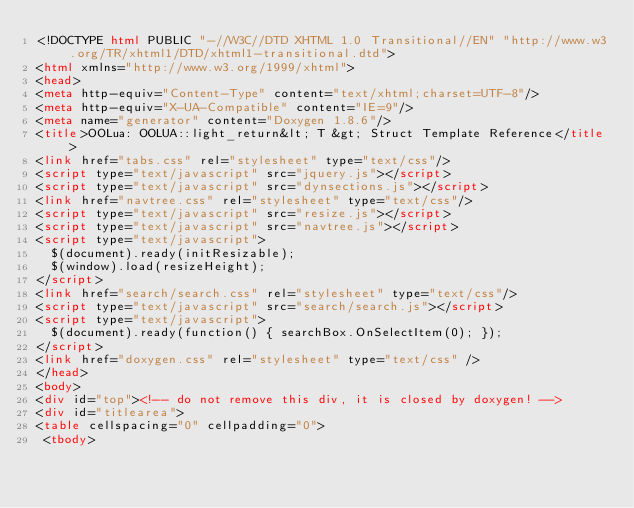<code> <loc_0><loc_0><loc_500><loc_500><_HTML_><!DOCTYPE html PUBLIC "-//W3C//DTD XHTML 1.0 Transitional//EN" "http://www.w3.org/TR/xhtml1/DTD/xhtml1-transitional.dtd">
<html xmlns="http://www.w3.org/1999/xhtml">
<head>
<meta http-equiv="Content-Type" content="text/xhtml;charset=UTF-8"/>
<meta http-equiv="X-UA-Compatible" content="IE=9"/>
<meta name="generator" content="Doxygen 1.8.6"/>
<title>OOLua: OOLUA::light_return&lt; T &gt; Struct Template Reference</title>
<link href="tabs.css" rel="stylesheet" type="text/css"/>
<script type="text/javascript" src="jquery.js"></script>
<script type="text/javascript" src="dynsections.js"></script>
<link href="navtree.css" rel="stylesheet" type="text/css"/>
<script type="text/javascript" src="resize.js"></script>
<script type="text/javascript" src="navtree.js"></script>
<script type="text/javascript">
  $(document).ready(initResizable);
  $(window).load(resizeHeight);
</script>
<link href="search/search.css" rel="stylesheet" type="text/css"/>
<script type="text/javascript" src="search/search.js"></script>
<script type="text/javascript">
  $(document).ready(function() { searchBox.OnSelectItem(0); });
</script>
<link href="doxygen.css" rel="stylesheet" type="text/css" />
</head>
<body>
<div id="top"><!-- do not remove this div, it is closed by doxygen! -->
<div id="titlearea">
<table cellspacing="0" cellpadding="0">
 <tbody></code> 